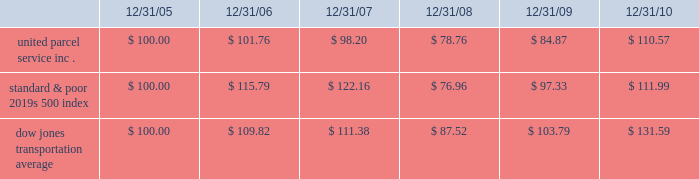Shareowner return performance graph the following performance graph and related information shall not be deemed 201csoliciting material 201d or to be 201cfiled 201d with the securities and exchange commission , nor shall such information be incorporated by reference into any future filing under the securities act of 1933 or securities exchange act of 1934 , each as amended , except to the extent that the company specifically incorporates such information by reference into such filing .
The following graph shows a five year comparison of cumulative total shareowners 2019 returns for our class b common stock , the standard & poor 2019s 500 index , and the dow jones transportation average .
The comparison of the total cumulative return on investment , which is the change in the quarterly stock price plus reinvested dividends for each of the quarterly periods , assumes that $ 100 was invested on december 31 , 2005 in the standard & poor 2019s 500 index , the dow jones transportation average , and our class b common stock .
Comparison of five year cumulative total return $ 40.00 $ 60.00 $ 80.00 $ 100.00 $ 120.00 $ 140.00 $ 160.00 201020092008200720062005 s&p 500 ups dj transport .

What was the difference in percentage cumulative total shareowners 2019 returns for united parcel service inc . versus the standard & poor 2019s 500 index for the five years ended 12/31/10? 
Computations: (((110.57 - 100) / 100) - ((111.99 - 100) / 100))
Answer: -0.0142. 